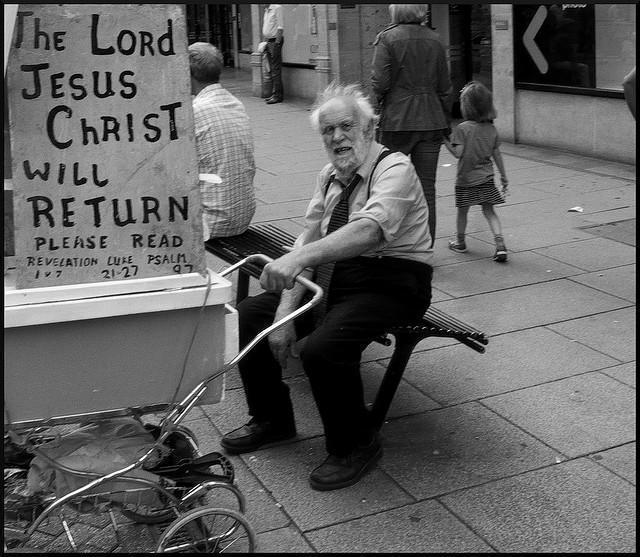What book is the man's sign referencing?
From the following four choices, select the correct answer to address the question.
Options: Dictionary, thesaurus, bible, encyclopedia. Bible. 